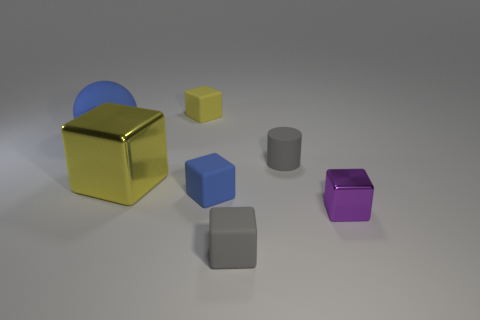Are there an equal number of large things that are in front of the big yellow metal cube and large metal cubes that are in front of the purple object?
Give a very brief answer. Yes. What number of objects are purple things or big green cubes?
Your answer should be compact. 1. The metallic cube that is the same size as the blue matte ball is what color?
Offer a very short reply. Yellow. How many things are blue matte things that are behind the tiny rubber cylinder or tiny matte objects on the left side of the small gray cylinder?
Provide a succinct answer. 4. Are there the same number of blue objects that are on the right side of the blue matte block and big matte objects?
Ensure brevity in your answer.  No. There is a shiny cube left of the blue cube; is it the same size as the matte cube behind the big sphere?
Provide a short and direct response. No. What number of other things are there of the same size as the gray matte cylinder?
Give a very brief answer. 4. Are there any large metallic objects that are in front of the blue matte thing that is on the right side of the yellow thing that is behind the big rubber object?
Offer a terse response. No. Is there any other thing that has the same color as the big sphere?
Provide a short and direct response. Yes. There is a object in front of the purple cube; what is its size?
Keep it short and to the point. Small. 